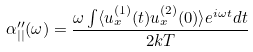Convert formula to latex. <formula><loc_0><loc_0><loc_500><loc_500>\alpha ^ { \prime \prime } _ { | | } ( \omega ) = \frac { \omega \int \langle u ^ { ( 1 ) } _ { x } ( t ) u ^ { ( 2 ) } _ { x } ( 0 ) \rangle e ^ { i \omega t } d t } { 2 k T }</formula> 